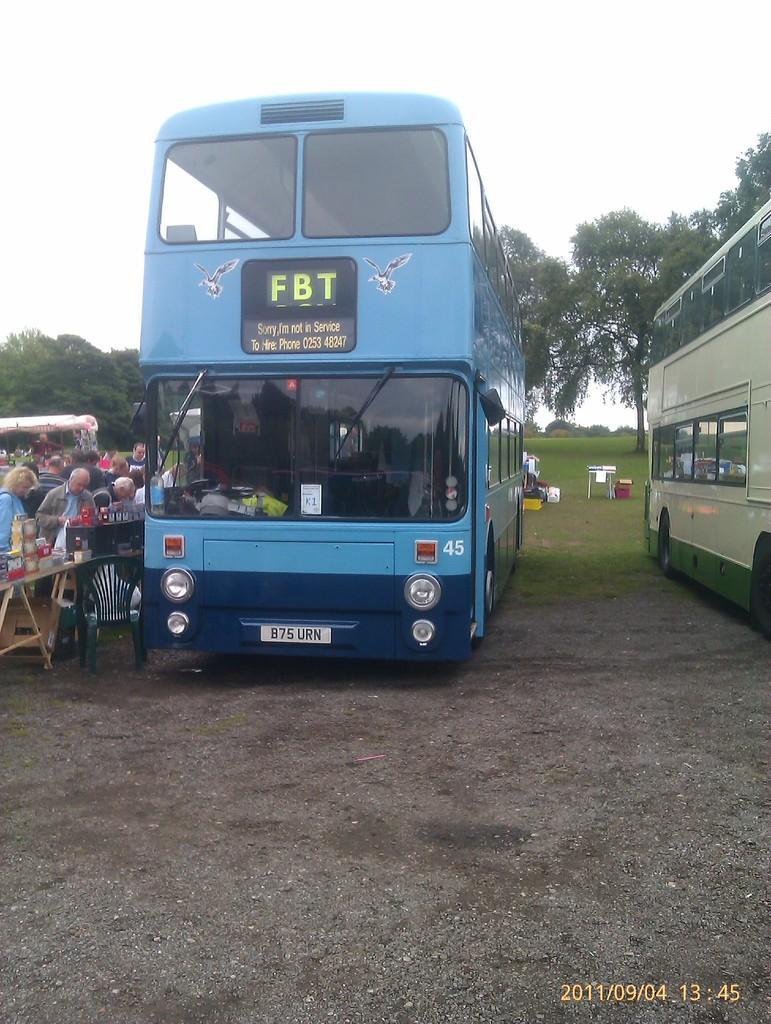Could you give a brief overview of what you see in this image? In this image in the front there is a bus which is blue in colour with some text written on it. On the left side there are persons and there is a table and there is an empty chair. On the right side there is a bus which is green in colour. In the background there are trees and there are objects. 